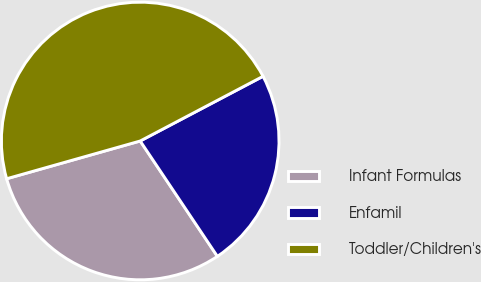Convert chart. <chart><loc_0><loc_0><loc_500><loc_500><pie_chart><fcel>Infant Formulas<fcel>Enfamil<fcel>Toddler/Children's<nl><fcel>30.0%<fcel>23.33%<fcel>46.67%<nl></chart> 